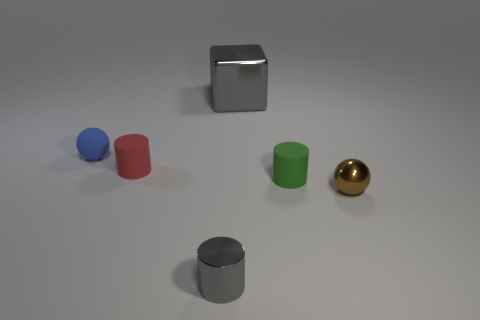How many rubber things are there?
Keep it short and to the point. 3. Are there any gray cylinders made of the same material as the blue object?
Keep it short and to the point. No. There is a object that is the same color as the tiny metallic cylinder; what is its size?
Offer a terse response. Large. There is a matte object that is on the left side of the red cylinder; is it the same size as the gray shiny object that is in front of the small blue sphere?
Offer a terse response. Yes. What size is the green matte cylinder that is in front of the red cylinder?
Ensure brevity in your answer.  Small. Are there any spheres of the same color as the tiny metal cylinder?
Make the answer very short. No. Is there a rubber ball that is right of the ball that is right of the tiny gray shiny cylinder?
Provide a short and direct response. No. Does the blue rubber thing have the same size as the gray shiny thing in front of the green matte object?
Ensure brevity in your answer.  Yes. There is a sphere that is to the right of the tiny matte object that is on the right side of the red rubber cylinder; is there a brown metallic sphere on the left side of it?
Your answer should be very brief. No. There is a small ball that is to the right of the shiny block; what is its material?
Give a very brief answer. Metal. 